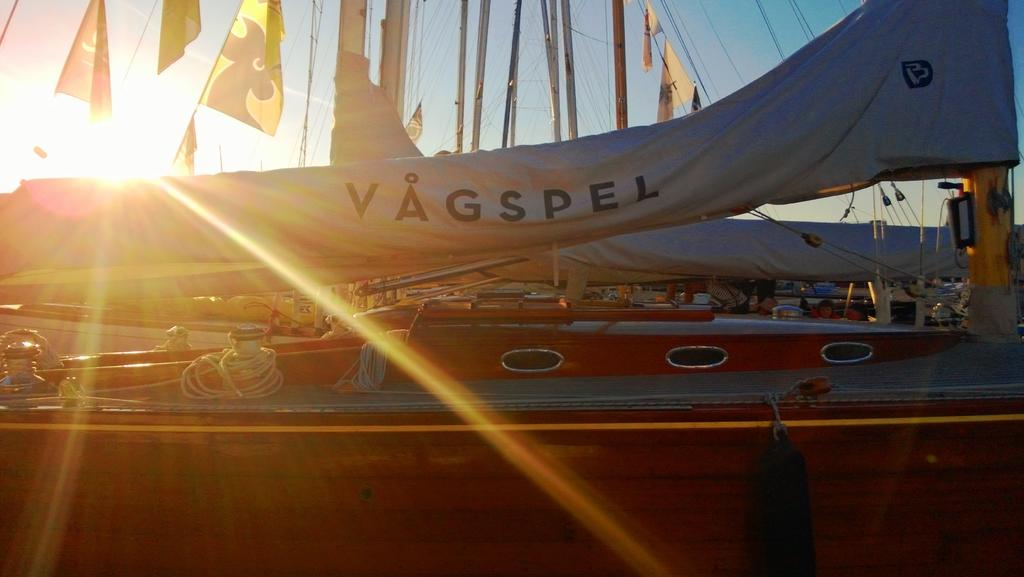Provide a one-sentence caption for the provided image. A large tarp is being lifted off of something with the word VAGSPEL. 